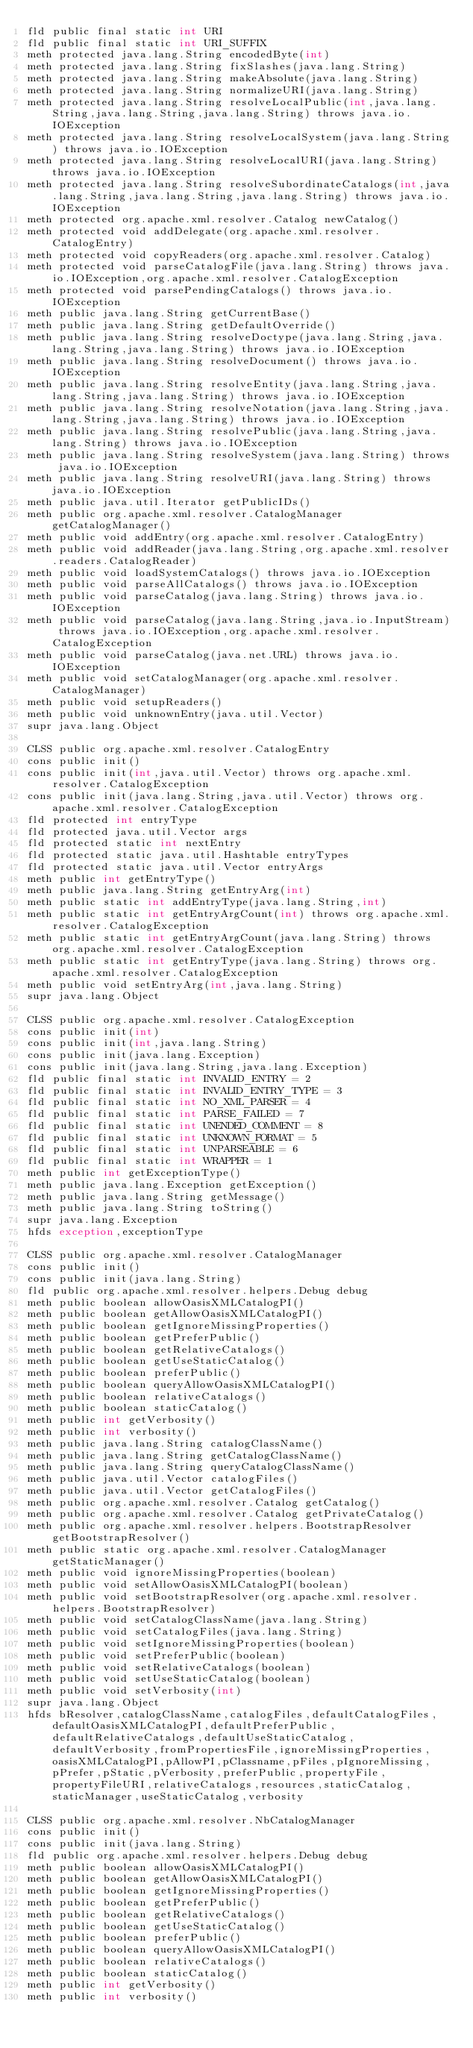<code> <loc_0><loc_0><loc_500><loc_500><_SML_>fld public final static int URI
fld public final static int URI_SUFFIX
meth protected java.lang.String encodedByte(int)
meth protected java.lang.String fixSlashes(java.lang.String)
meth protected java.lang.String makeAbsolute(java.lang.String)
meth protected java.lang.String normalizeURI(java.lang.String)
meth protected java.lang.String resolveLocalPublic(int,java.lang.String,java.lang.String,java.lang.String) throws java.io.IOException
meth protected java.lang.String resolveLocalSystem(java.lang.String) throws java.io.IOException
meth protected java.lang.String resolveLocalURI(java.lang.String) throws java.io.IOException
meth protected java.lang.String resolveSubordinateCatalogs(int,java.lang.String,java.lang.String,java.lang.String) throws java.io.IOException
meth protected org.apache.xml.resolver.Catalog newCatalog()
meth protected void addDelegate(org.apache.xml.resolver.CatalogEntry)
meth protected void copyReaders(org.apache.xml.resolver.Catalog)
meth protected void parseCatalogFile(java.lang.String) throws java.io.IOException,org.apache.xml.resolver.CatalogException
meth protected void parsePendingCatalogs() throws java.io.IOException
meth public java.lang.String getCurrentBase()
meth public java.lang.String getDefaultOverride()
meth public java.lang.String resolveDoctype(java.lang.String,java.lang.String,java.lang.String) throws java.io.IOException
meth public java.lang.String resolveDocument() throws java.io.IOException
meth public java.lang.String resolveEntity(java.lang.String,java.lang.String,java.lang.String) throws java.io.IOException
meth public java.lang.String resolveNotation(java.lang.String,java.lang.String,java.lang.String) throws java.io.IOException
meth public java.lang.String resolvePublic(java.lang.String,java.lang.String) throws java.io.IOException
meth public java.lang.String resolveSystem(java.lang.String) throws java.io.IOException
meth public java.lang.String resolveURI(java.lang.String) throws java.io.IOException
meth public java.util.Iterator getPublicIDs()
meth public org.apache.xml.resolver.CatalogManager getCatalogManager()
meth public void addEntry(org.apache.xml.resolver.CatalogEntry)
meth public void addReader(java.lang.String,org.apache.xml.resolver.readers.CatalogReader)
meth public void loadSystemCatalogs() throws java.io.IOException
meth public void parseAllCatalogs() throws java.io.IOException
meth public void parseCatalog(java.lang.String) throws java.io.IOException
meth public void parseCatalog(java.lang.String,java.io.InputStream) throws java.io.IOException,org.apache.xml.resolver.CatalogException
meth public void parseCatalog(java.net.URL) throws java.io.IOException
meth public void setCatalogManager(org.apache.xml.resolver.CatalogManager)
meth public void setupReaders()
meth public void unknownEntry(java.util.Vector)
supr java.lang.Object

CLSS public org.apache.xml.resolver.CatalogEntry
cons public init()
cons public init(int,java.util.Vector) throws org.apache.xml.resolver.CatalogException
cons public init(java.lang.String,java.util.Vector) throws org.apache.xml.resolver.CatalogException
fld protected int entryType
fld protected java.util.Vector args
fld protected static int nextEntry
fld protected static java.util.Hashtable entryTypes
fld protected static java.util.Vector entryArgs
meth public int getEntryType()
meth public java.lang.String getEntryArg(int)
meth public static int addEntryType(java.lang.String,int)
meth public static int getEntryArgCount(int) throws org.apache.xml.resolver.CatalogException
meth public static int getEntryArgCount(java.lang.String) throws org.apache.xml.resolver.CatalogException
meth public static int getEntryType(java.lang.String) throws org.apache.xml.resolver.CatalogException
meth public void setEntryArg(int,java.lang.String)
supr java.lang.Object

CLSS public org.apache.xml.resolver.CatalogException
cons public init(int)
cons public init(int,java.lang.String)
cons public init(java.lang.Exception)
cons public init(java.lang.String,java.lang.Exception)
fld public final static int INVALID_ENTRY = 2
fld public final static int INVALID_ENTRY_TYPE = 3
fld public final static int NO_XML_PARSER = 4
fld public final static int PARSE_FAILED = 7
fld public final static int UNENDED_COMMENT = 8
fld public final static int UNKNOWN_FORMAT = 5
fld public final static int UNPARSEABLE = 6
fld public final static int WRAPPER = 1
meth public int getExceptionType()
meth public java.lang.Exception getException()
meth public java.lang.String getMessage()
meth public java.lang.String toString()
supr java.lang.Exception
hfds exception,exceptionType

CLSS public org.apache.xml.resolver.CatalogManager
cons public init()
cons public init(java.lang.String)
fld public org.apache.xml.resolver.helpers.Debug debug
meth public boolean allowOasisXMLCatalogPI()
meth public boolean getAllowOasisXMLCatalogPI()
meth public boolean getIgnoreMissingProperties()
meth public boolean getPreferPublic()
meth public boolean getRelativeCatalogs()
meth public boolean getUseStaticCatalog()
meth public boolean preferPublic()
meth public boolean queryAllowOasisXMLCatalogPI()
meth public boolean relativeCatalogs()
meth public boolean staticCatalog()
meth public int getVerbosity()
meth public int verbosity()
meth public java.lang.String catalogClassName()
meth public java.lang.String getCatalogClassName()
meth public java.lang.String queryCatalogClassName()
meth public java.util.Vector catalogFiles()
meth public java.util.Vector getCatalogFiles()
meth public org.apache.xml.resolver.Catalog getCatalog()
meth public org.apache.xml.resolver.Catalog getPrivateCatalog()
meth public org.apache.xml.resolver.helpers.BootstrapResolver getBootstrapResolver()
meth public static org.apache.xml.resolver.CatalogManager getStaticManager()
meth public void ignoreMissingProperties(boolean)
meth public void setAllowOasisXMLCatalogPI(boolean)
meth public void setBootstrapResolver(org.apache.xml.resolver.helpers.BootstrapResolver)
meth public void setCatalogClassName(java.lang.String)
meth public void setCatalogFiles(java.lang.String)
meth public void setIgnoreMissingProperties(boolean)
meth public void setPreferPublic(boolean)
meth public void setRelativeCatalogs(boolean)
meth public void setUseStaticCatalog(boolean)
meth public void setVerbosity(int)
supr java.lang.Object
hfds bResolver,catalogClassName,catalogFiles,defaultCatalogFiles,defaultOasisXMLCatalogPI,defaultPreferPublic,defaultRelativeCatalogs,defaultUseStaticCatalog,defaultVerbosity,fromPropertiesFile,ignoreMissingProperties,oasisXMLCatalogPI,pAllowPI,pClassname,pFiles,pIgnoreMissing,pPrefer,pStatic,pVerbosity,preferPublic,propertyFile,propertyFileURI,relativeCatalogs,resources,staticCatalog,staticManager,useStaticCatalog,verbosity

CLSS public org.apache.xml.resolver.NbCatalogManager
cons public init()
cons public init(java.lang.String)
fld public org.apache.xml.resolver.helpers.Debug debug
meth public boolean allowOasisXMLCatalogPI()
meth public boolean getAllowOasisXMLCatalogPI()
meth public boolean getIgnoreMissingProperties()
meth public boolean getPreferPublic()
meth public boolean getRelativeCatalogs()
meth public boolean getUseStaticCatalog()
meth public boolean preferPublic()
meth public boolean queryAllowOasisXMLCatalogPI()
meth public boolean relativeCatalogs()
meth public boolean staticCatalog()
meth public int getVerbosity()
meth public int verbosity()</code> 